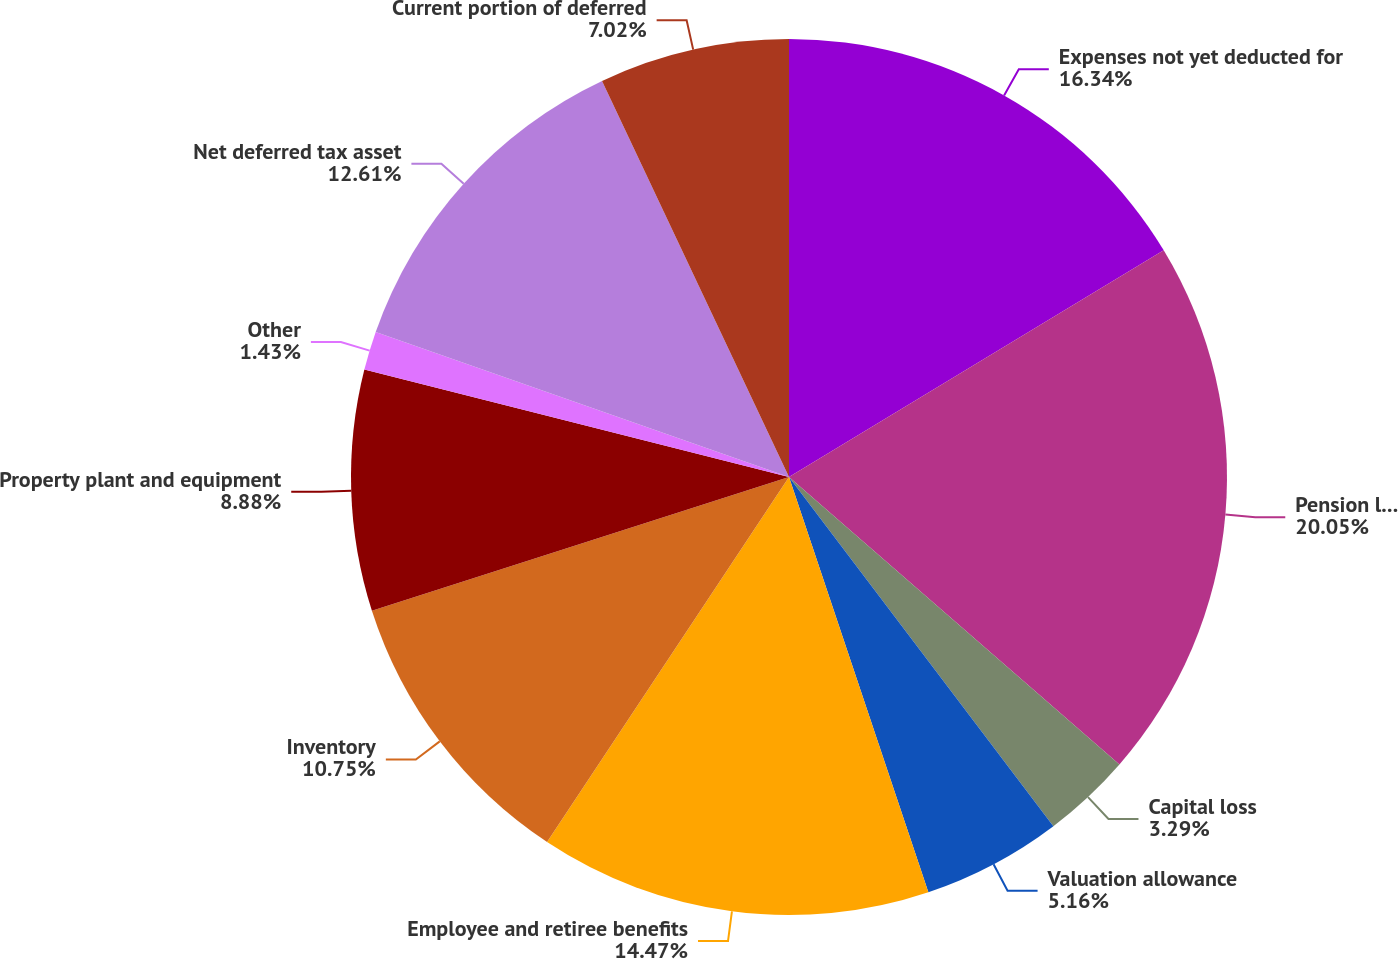Convert chart to OTSL. <chart><loc_0><loc_0><loc_500><loc_500><pie_chart><fcel>Expenses not yet deducted for<fcel>Pension liability not yet<fcel>Capital loss<fcel>Valuation allowance<fcel>Employee and retiree benefits<fcel>Inventory<fcel>Property plant and equipment<fcel>Other<fcel>Net deferred tax asset<fcel>Current portion of deferred<nl><fcel>16.34%<fcel>20.06%<fcel>3.29%<fcel>5.16%<fcel>14.47%<fcel>10.75%<fcel>8.88%<fcel>1.43%<fcel>12.61%<fcel>7.02%<nl></chart> 